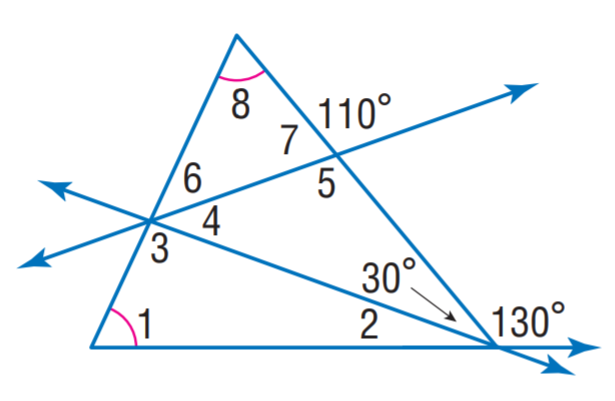Question: Find m \angle 7.
Choices:
A. 50
B. 65
C. 70
D. 85
Answer with the letter. Answer: C Question: Find m \angle 3.
Choices:
A. 65
B. 70
C. 95
D. 110
Answer with the letter. Answer: C Question: Find m \angle 4.
Choices:
A. 20
B. 30
C. 40
D. 65
Answer with the letter. Answer: C Question: Find m \angle 5.
Choices:
A. 95
B. 100
C. 110
D. 115
Answer with the letter. Answer: C Question: Find m \angle 2.
Choices:
A. 20
B. 40
C. 45
D. 65
Answer with the letter. Answer: A Question: Find m \angle 1.
Choices:
A. 20
B. 40
C. 65
D. 95
Answer with the letter. Answer: C Question: Find m \angle 6.
Choices:
A. 30
B. 40
C. 45
D. 65
Answer with the letter. Answer: C 